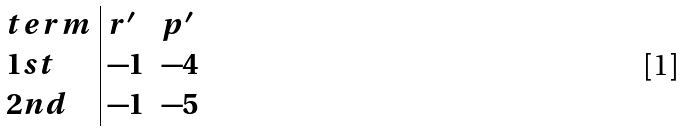<formula> <loc_0><loc_0><loc_500><loc_500>\begin{array} { l | l l } t e r m & r ^ { \prime } & p ^ { \prime } \\ 1 s t & - 1 & - 4 \\ 2 n d & - 1 & - 5 \end{array}</formula> 